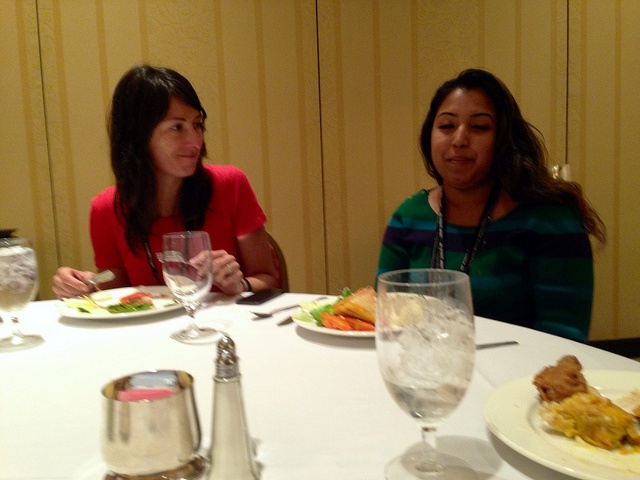Describe the objects in this image and their specific colors. I can see dining table in tan, ivory, and beige tones, people in tan, black, maroon, and brown tones, people in tan, black, maroon, and brown tones, wine glass in tan tones, and cup in tan tones in this image. 